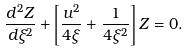Convert formula to latex. <formula><loc_0><loc_0><loc_500><loc_500>\frac { d ^ { 2 } Z } { d \xi ^ { 2 } } + \left [ \frac { u ^ { 2 } } { 4 \xi } + \frac { 1 } { 4 \xi ^ { 2 } } \right ] Z = 0 .</formula> 